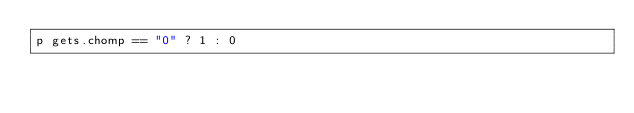Convert code to text. <code><loc_0><loc_0><loc_500><loc_500><_Ruby_>p gets.chomp == "0" ? 1 : 0</code> 